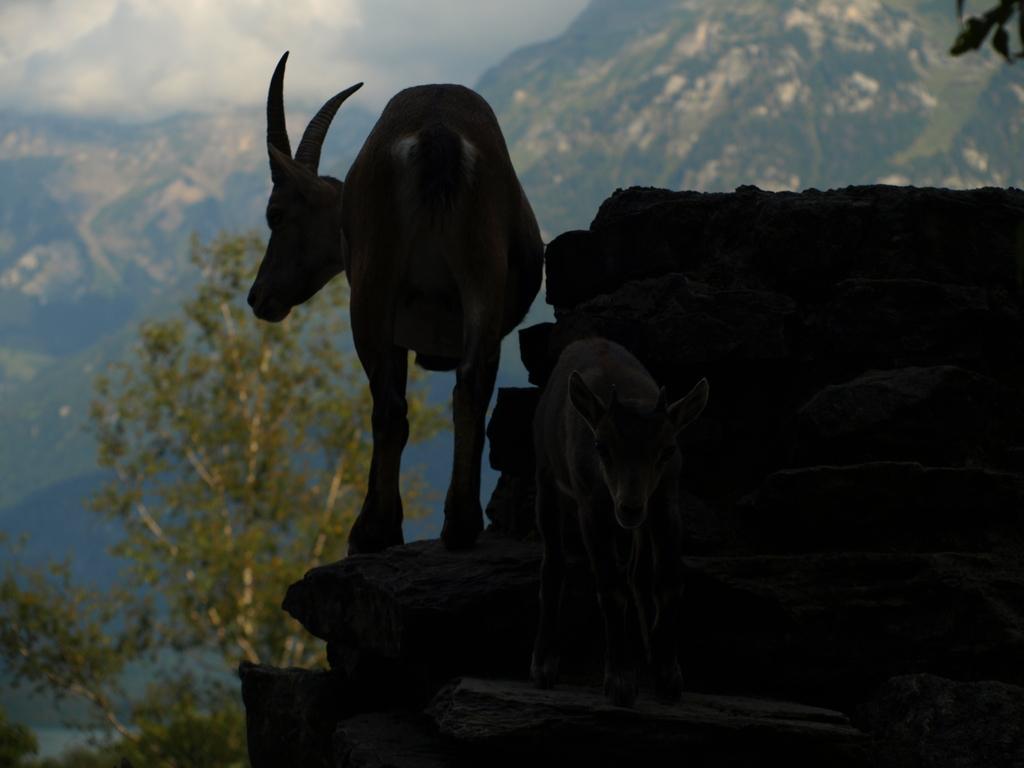In one or two sentences, can you explain what this image depicts? In this image in the center there are two animals, and on the right side it looks like a wall. In the background there are mountains and trees, at the top there is sky and clouds. 